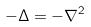Convert formula to latex. <formula><loc_0><loc_0><loc_500><loc_500>- \Delta = - \nabla ^ { 2 }</formula> 